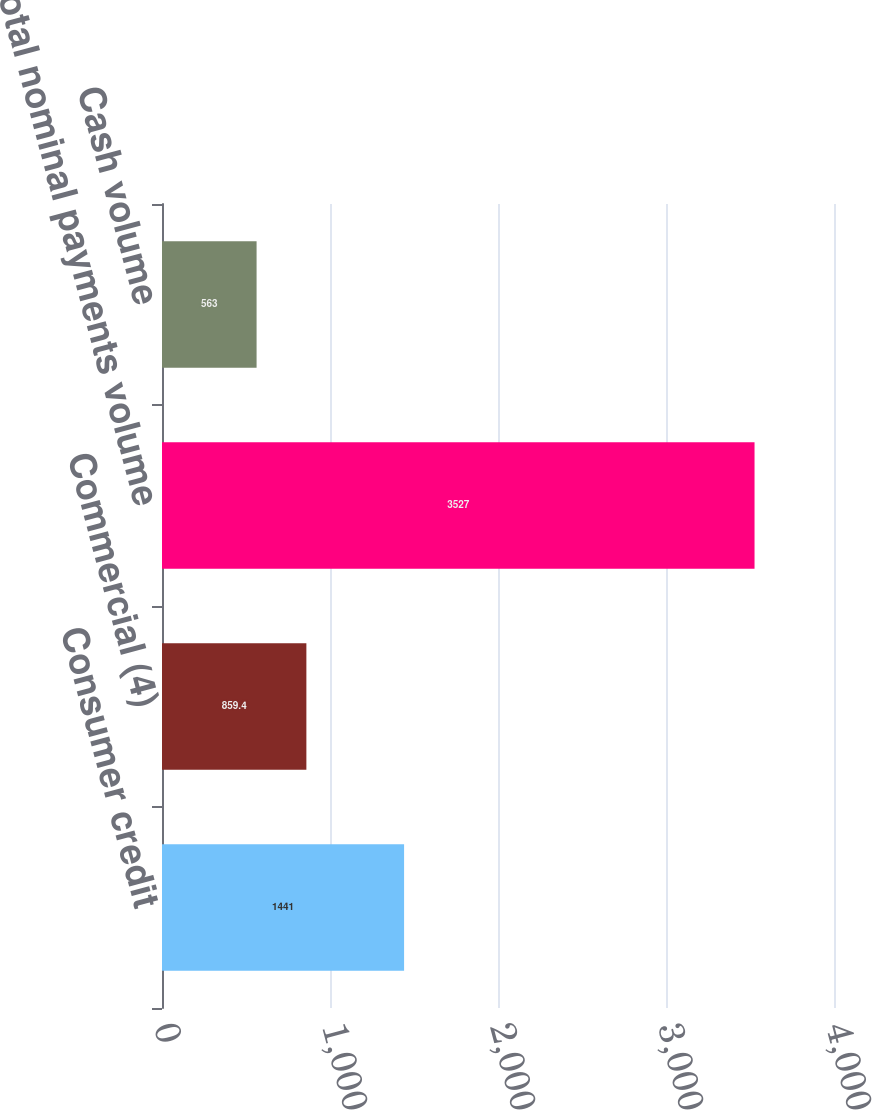Convert chart. <chart><loc_0><loc_0><loc_500><loc_500><bar_chart><fcel>Consumer credit<fcel>Commercial (4)<fcel>Total nominal payments volume<fcel>Cash volume<nl><fcel>1441<fcel>859.4<fcel>3527<fcel>563<nl></chart> 